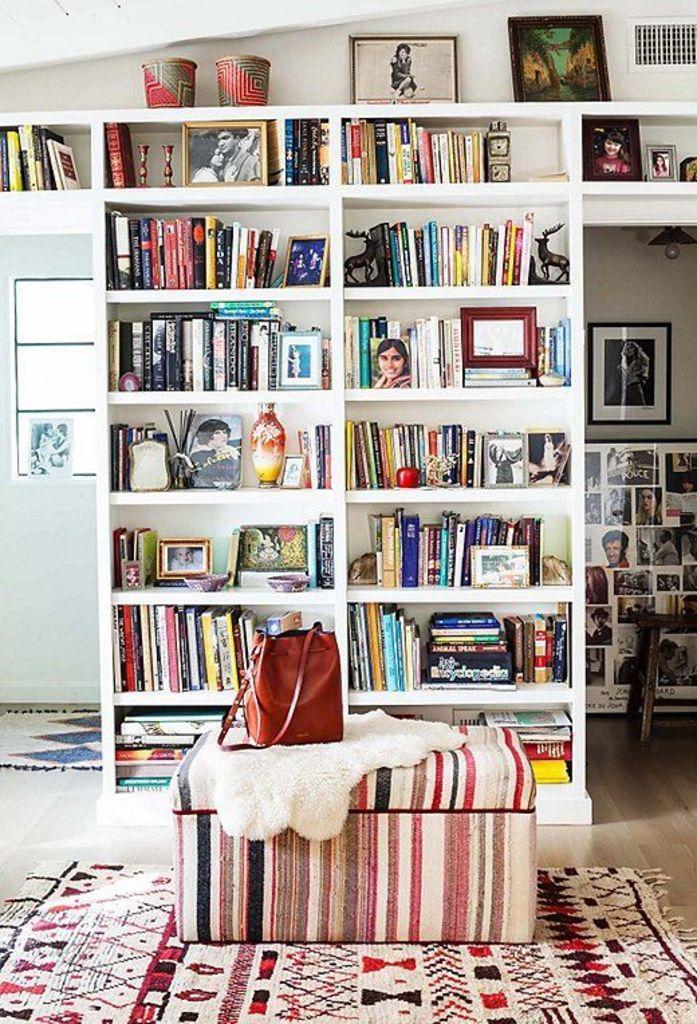How would you summarize this image in a sentence or two? In this picture I can see a bench with a bag and a cloth on it, there are mats on the floor, there are books, frames and other objects in the racks, there are frames attached to the wall, there is a light, and in the background there is a wall and a window. 